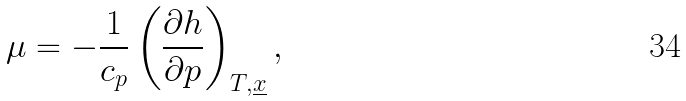<formula> <loc_0><loc_0><loc_500><loc_500>\mu = - \frac { 1 } { c _ { p } } \left ( \frac { \partial h } { \partial p } \right ) _ { T , { \underline { x } } } ,</formula> 